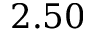<formula> <loc_0><loc_0><loc_500><loc_500>2 . 5 0</formula> 